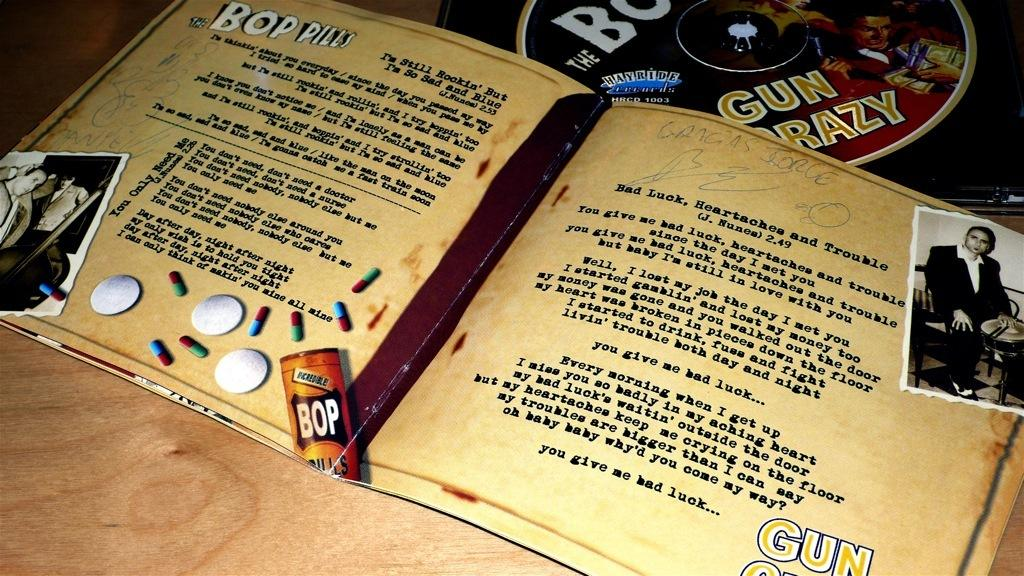<image>
Relay a brief, clear account of the picture shown. A book about Bop Pills has lyrics inside written by J Nunea 